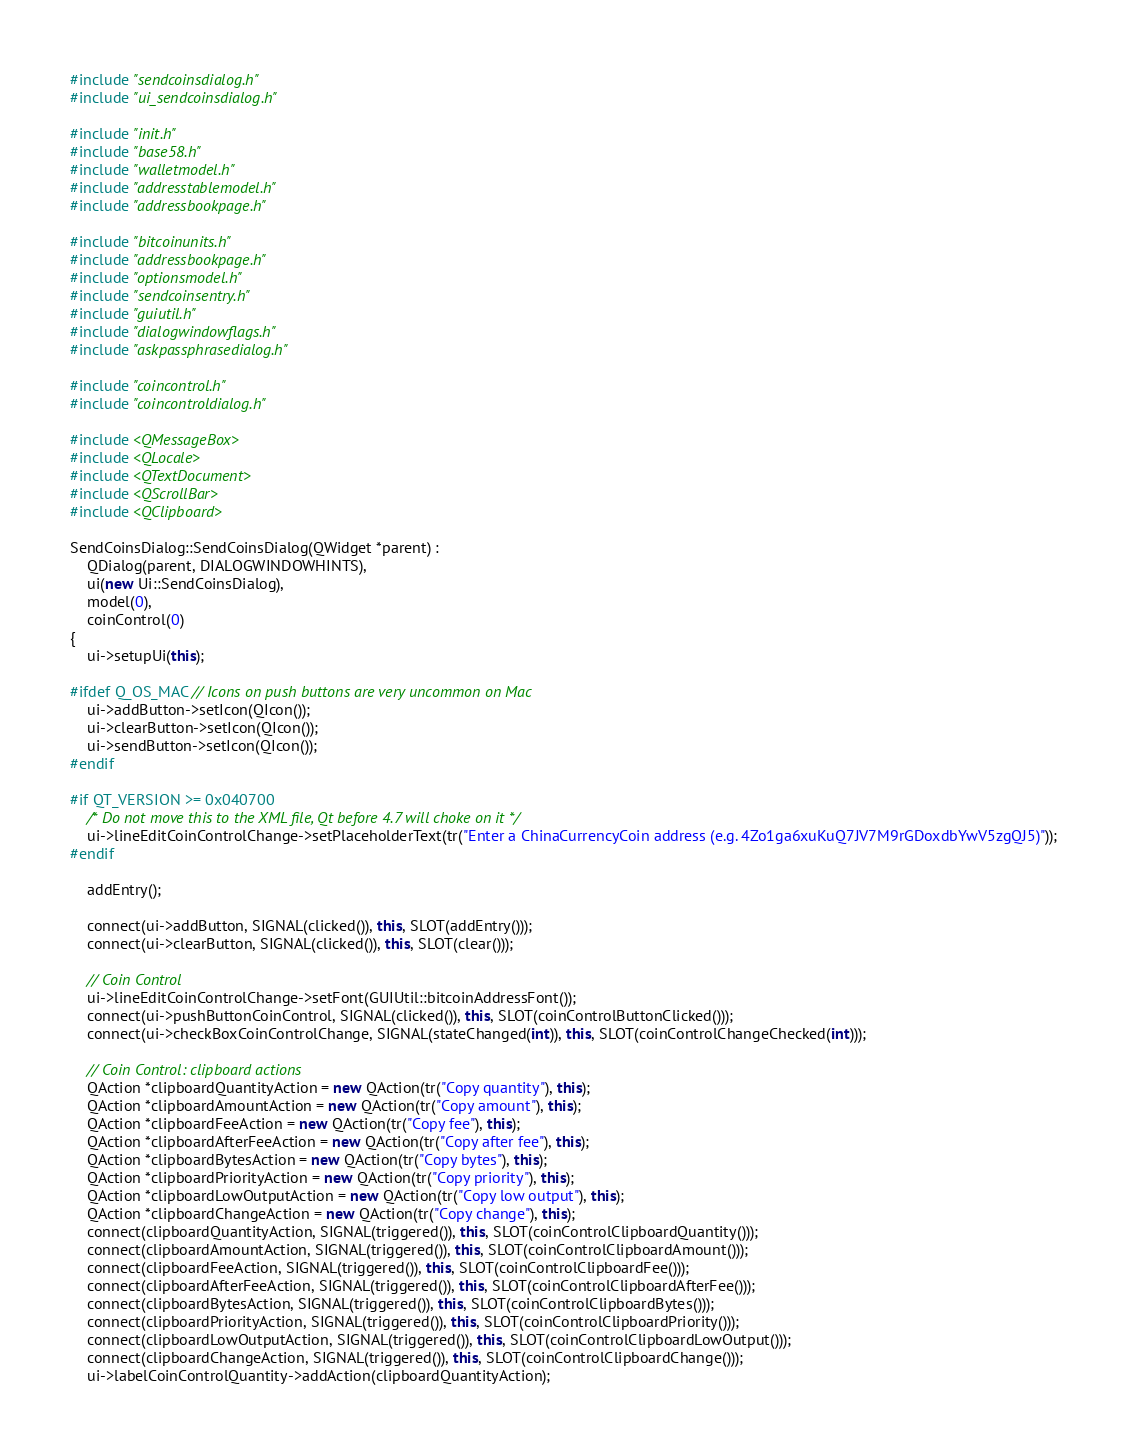<code> <loc_0><loc_0><loc_500><loc_500><_C++_>#include "sendcoinsdialog.h"
#include "ui_sendcoinsdialog.h"

#include "init.h"
#include "base58.h"
#include "walletmodel.h"
#include "addresstablemodel.h"
#include "addressbookpage.h"

#include "bitcoinunits.h"
#include "addressbookpage.h"
#include "optionsmodel.h"
#include "sendcoinsentry.h"
#include "guiutil.h"
#include "dialogwindowflags.h"
#include "askpassphrasedialog.h"

#include "coincontrol.h"
#include "coincontroldialog.h"

#include <QMessageBox>
#include <QLocale>
#include <QTextDocument>
#include <QScrollBar>
#include <QClipboard>

SendCoinsDialog::SendCoinsDialog(QWidget *parent) :
    QDialog(parent, DIALOGWINDOWHINTS),
    ui(new Ui::SendCoinsDialog),
    model(0),
    coinControl(0)
{
    ui->setupUi(this);

#ifdef Q_OS_MAC // Icons on push buttons are very uncommon on Mac
    ui->addButton->setIcon(QIcon());
    ui->clearButton->setIcon(QIcon());
    ui->sendButton->setIcon(QIcon());
#endif

#if QT_VERSION >= 0x040700
    /* Do not move this to the XML file, Qt before 4.7 will choke on it */
    ui->lineEditCoinControlChange->setPlaceholderText(tr("Enter a ChinaCurrencyCoin address (e.g. 4Zo1ga6xuKuQ7JV7M9rGDoxdbYwV5zgQJ5)"));
#endif

    addEntry();

    connect(ui->addButton, SIGNAL(clicked()), this, SLOT(addEntry()));
    connect(ui->clearButton, SIGNAL(clicked()), this, SLOT(clear()));

    // Coin Control
    ui->lineEditCoinControlChange->setFont(GUIUtil::bitcoinAddressFont());
    connect(ui->pushButtonCoinControl, SIGNAL(clicked()), this, SLOT(coinControlButtonClicked()));
    connect(ui->checkBoxCoinControlChange, SIGNAL(stateChanged(int)), this, SLOT(coinControlChangeChecked(int)));

    // Coin Control: clipboard actions
    QAction *clipboardQuantityAction = new QAction(tr("Copy quantity"), this);
    QAction *clipboardAmountAction = new QAction(tr("Copy amount"), this);
    QAction *clipboardFeeAction = new QAction(tr("Copy fee"), this);
    QAction *clipboardAfterFeeAction = new QAction(tr("Copy after fee"), this);
    QAction *clipboardBytesAction = new QAction(tr("Copy bytes"), this);
    QAction *clipboardPriorityAction = new QAction(tr("Copy priority"), this);
    QAction *clipboardLowOutputAction = new QAction(tr("Copy low output"), this);
    QAction *clipboardChangeAction = new QAction(tr("Copy change"), this);
    connect(clipboardQuantityAction, SIGNAL(triggered()), this, SLOT(coinControlClipboardQuantity()));
    connect(clipboardAmountAction, SIGNAL(triggered()), this, SLOT(coinControlClipboardAmount()));
    connect(clipboardFeeAction, SIGNAL(triggered()), this, SLOT(coinControlClipboardFee()));
    connect(clipboardAfterFeeAction, SIGNAL(triggered()), this, SLOT(coinControlClipboardAfterFee()));
    connect(clipboardBytesAction, SIGNAL(triggered()), this, SLOT(coinControlClipboardBytes()));
    connect(clipboardPriorityAction, SIGNAL(triggered()), this, SLOT(coinControlClipboardPriority()));
    connect(clipboardLowOutputAction, SIGNAL(triggered()), this, SLOT(coinControlClipboardLowOutput()));
    connect(clipboardChangeAction, SIGNAL(triggered()), this, SLOT(coinControlClipboardChange()));
    ui->labelCoinControlQuantity->addAction(clipboardQuantityAction);</code> 